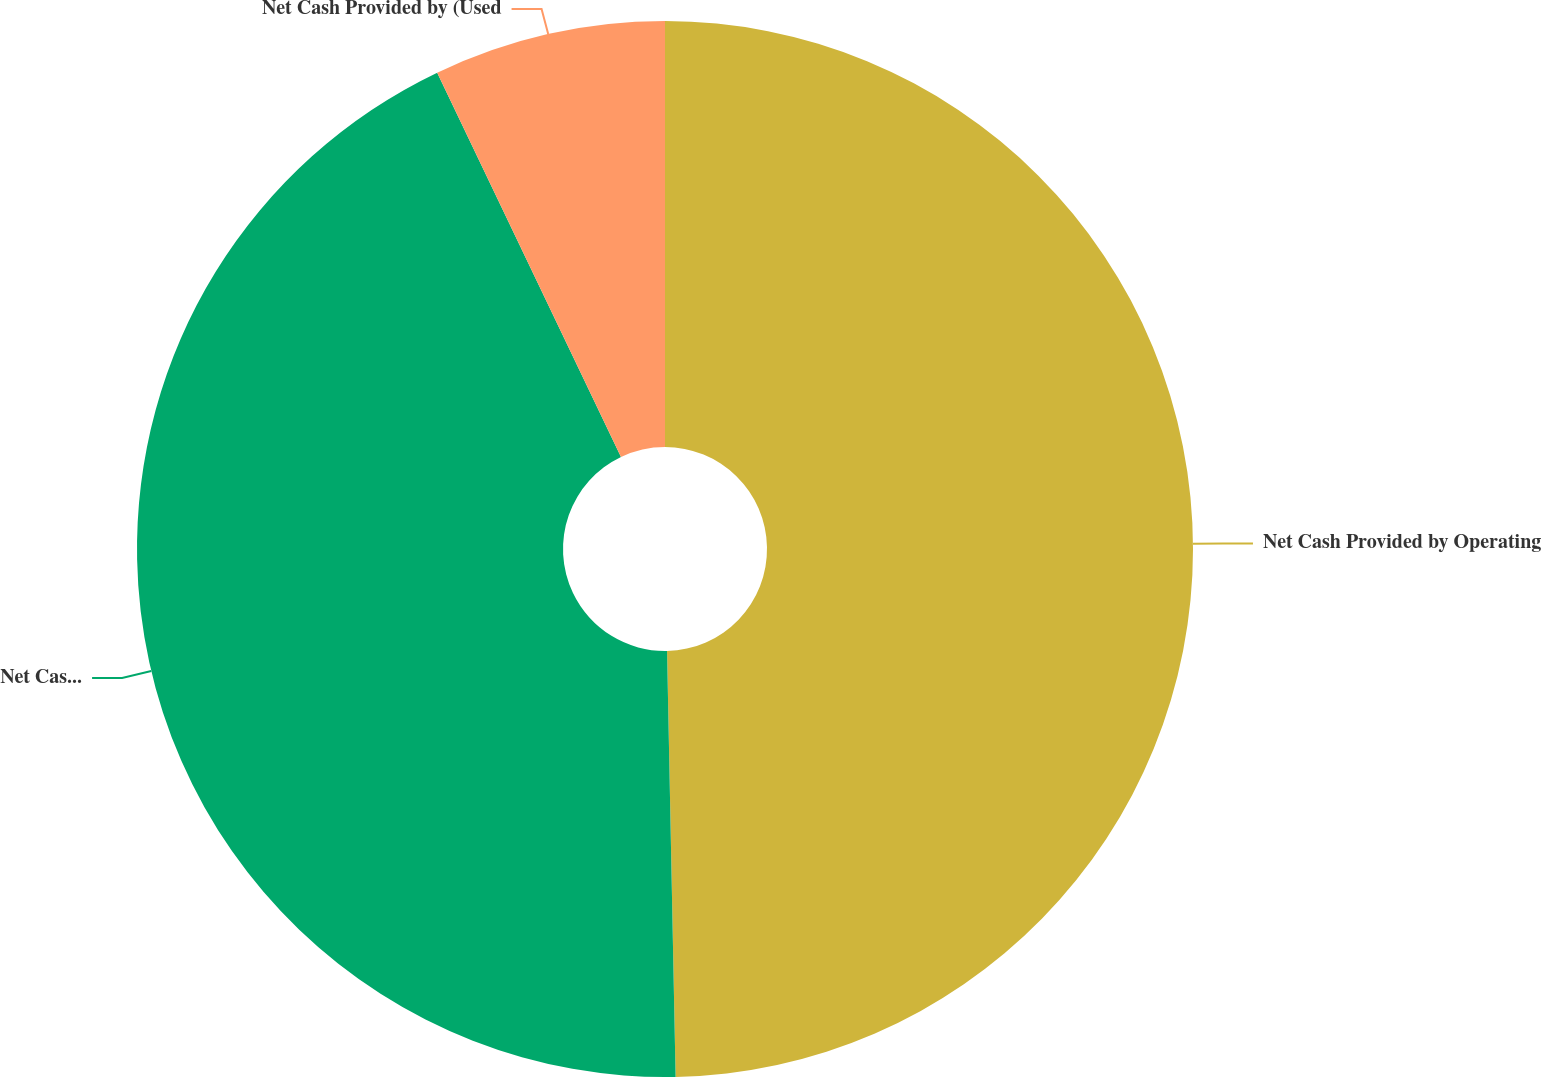<chart> <loc_0><loc_0><loc_500><loc_500><pie_chart><fcel>Net Cash Provided by Operating<fcel>Net Cash Used for Investing<fcel>Net Cash Provided by (Used<nl><fcel>49.68%<fcel>43.22%<fcel>7.1%<nl></chart> 